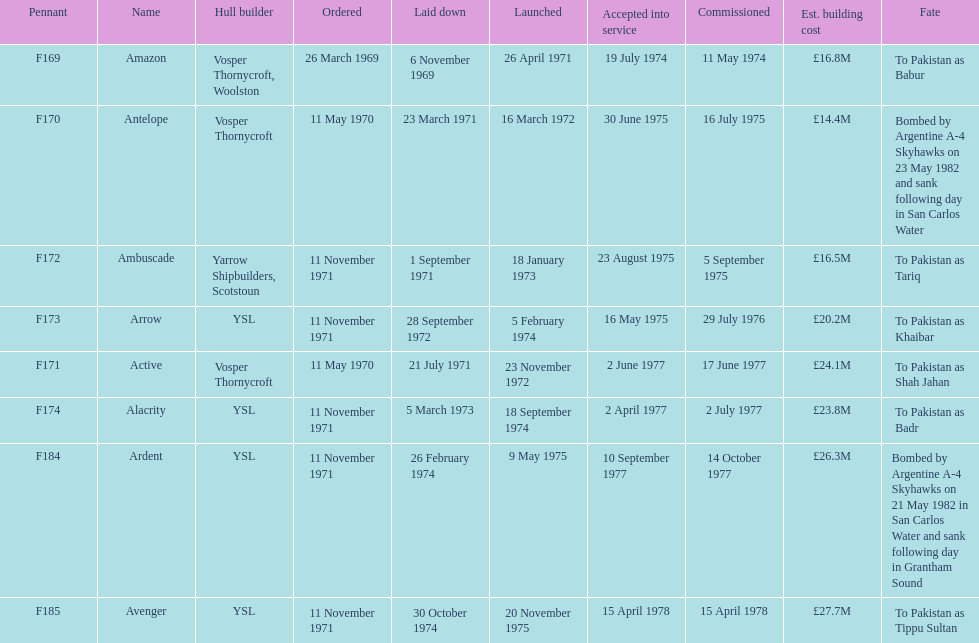What is the last recorded pennant? F185. 